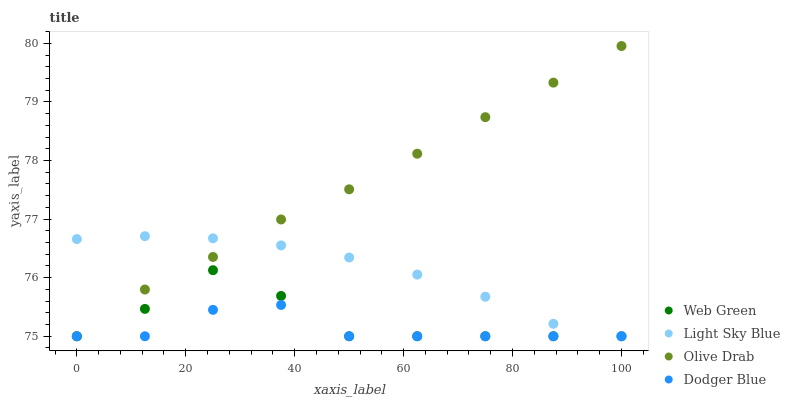Does Dodger Blue have the minimum area under the curve?
Answer yes or no. Yes. Does Olive Drab have the maximum area under the curve?
Answer yes or no. Yes. Does Olive Drab have the minimum area under the curve?
Answer yes or no. No. Does Dodger Blue have the maximum area under the curve?
Answer yes or no. No. Is Olive Drab the smoothest?
Answer yes or no. Yes. Is Web Green the roughest?
Answer yes or no. Yes. Is Dodger Blue the smoothest?
Answer yes or no. No. Is Dodger Blue the roughest?
Answer yes or no. No. Does Light Sky Blue have the lowest value?
Answer yes or no. Yes. Does Olive Drab have the highest value?
Answer yes or no. Yes. Does Dodger Blue have the highest value?
Answer yes or no. No. Does Web Green intersect Olive Drab?
Answer yes or no. Yes. Is Web Green less than Olive Drab?
Answer yes or no. No. Is Web Green greater than Olive Drab?
Answer yes or no. No. 